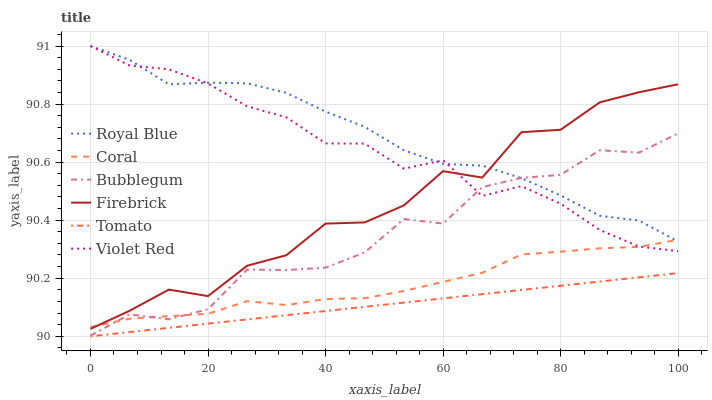Does Tomato have the minimum area under the curve?
Answer yes or no. Yes. Does Royal Blue have the maximum area under the curve?
Answer yes or no. Yes. Does Violet Red have the minimum area under the curve?
Answer yes or no. No. Does Violet Red have the maximum area under the curve?
Answer yes or no. No. Is Tomato the smoothest?
Answer yes or no. Yes. Is Firebrick the roughest?
Answer yes or no. Yes. Is Violet Red the smoothest?
Answer yes or no. No. Is Violet Red the roughest?
Answer yes or no. No. Does Tomato have the lowest value?
Answer yes or no. Yes. Does Violet Red have the lowest value?
Answer yes or no. No. Does Royal Blue have the highest value?
Answer yes or no. Yes. Does Coral have the highest value?
Answer yes or no. No. Is Bubblegum less than Firebrick?
Answer yes or no. Yes. Is Violet Red greater than Tomato?
Answer yes or no. Yes. Does Royal Blue intersect Firebrick?
Answer yes or no. Yes. Is Royal Blue less than Firebrick?
Answer yes or no. No. Is Royal Blue greater than Firebrick?
Answer yes or no. No. Does Bubblegum intersect Firebrick?
Answer yes or no. No. 